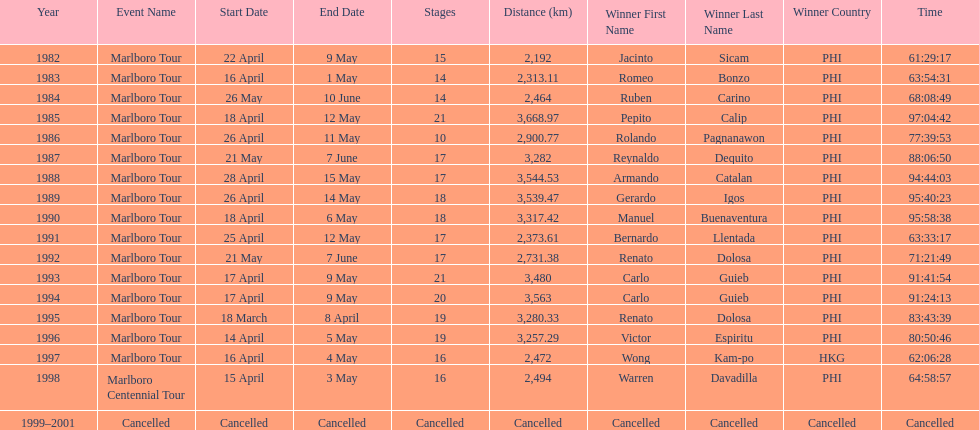What was the largest distance traveled for the marlboro tour? 3,668.97 km. 